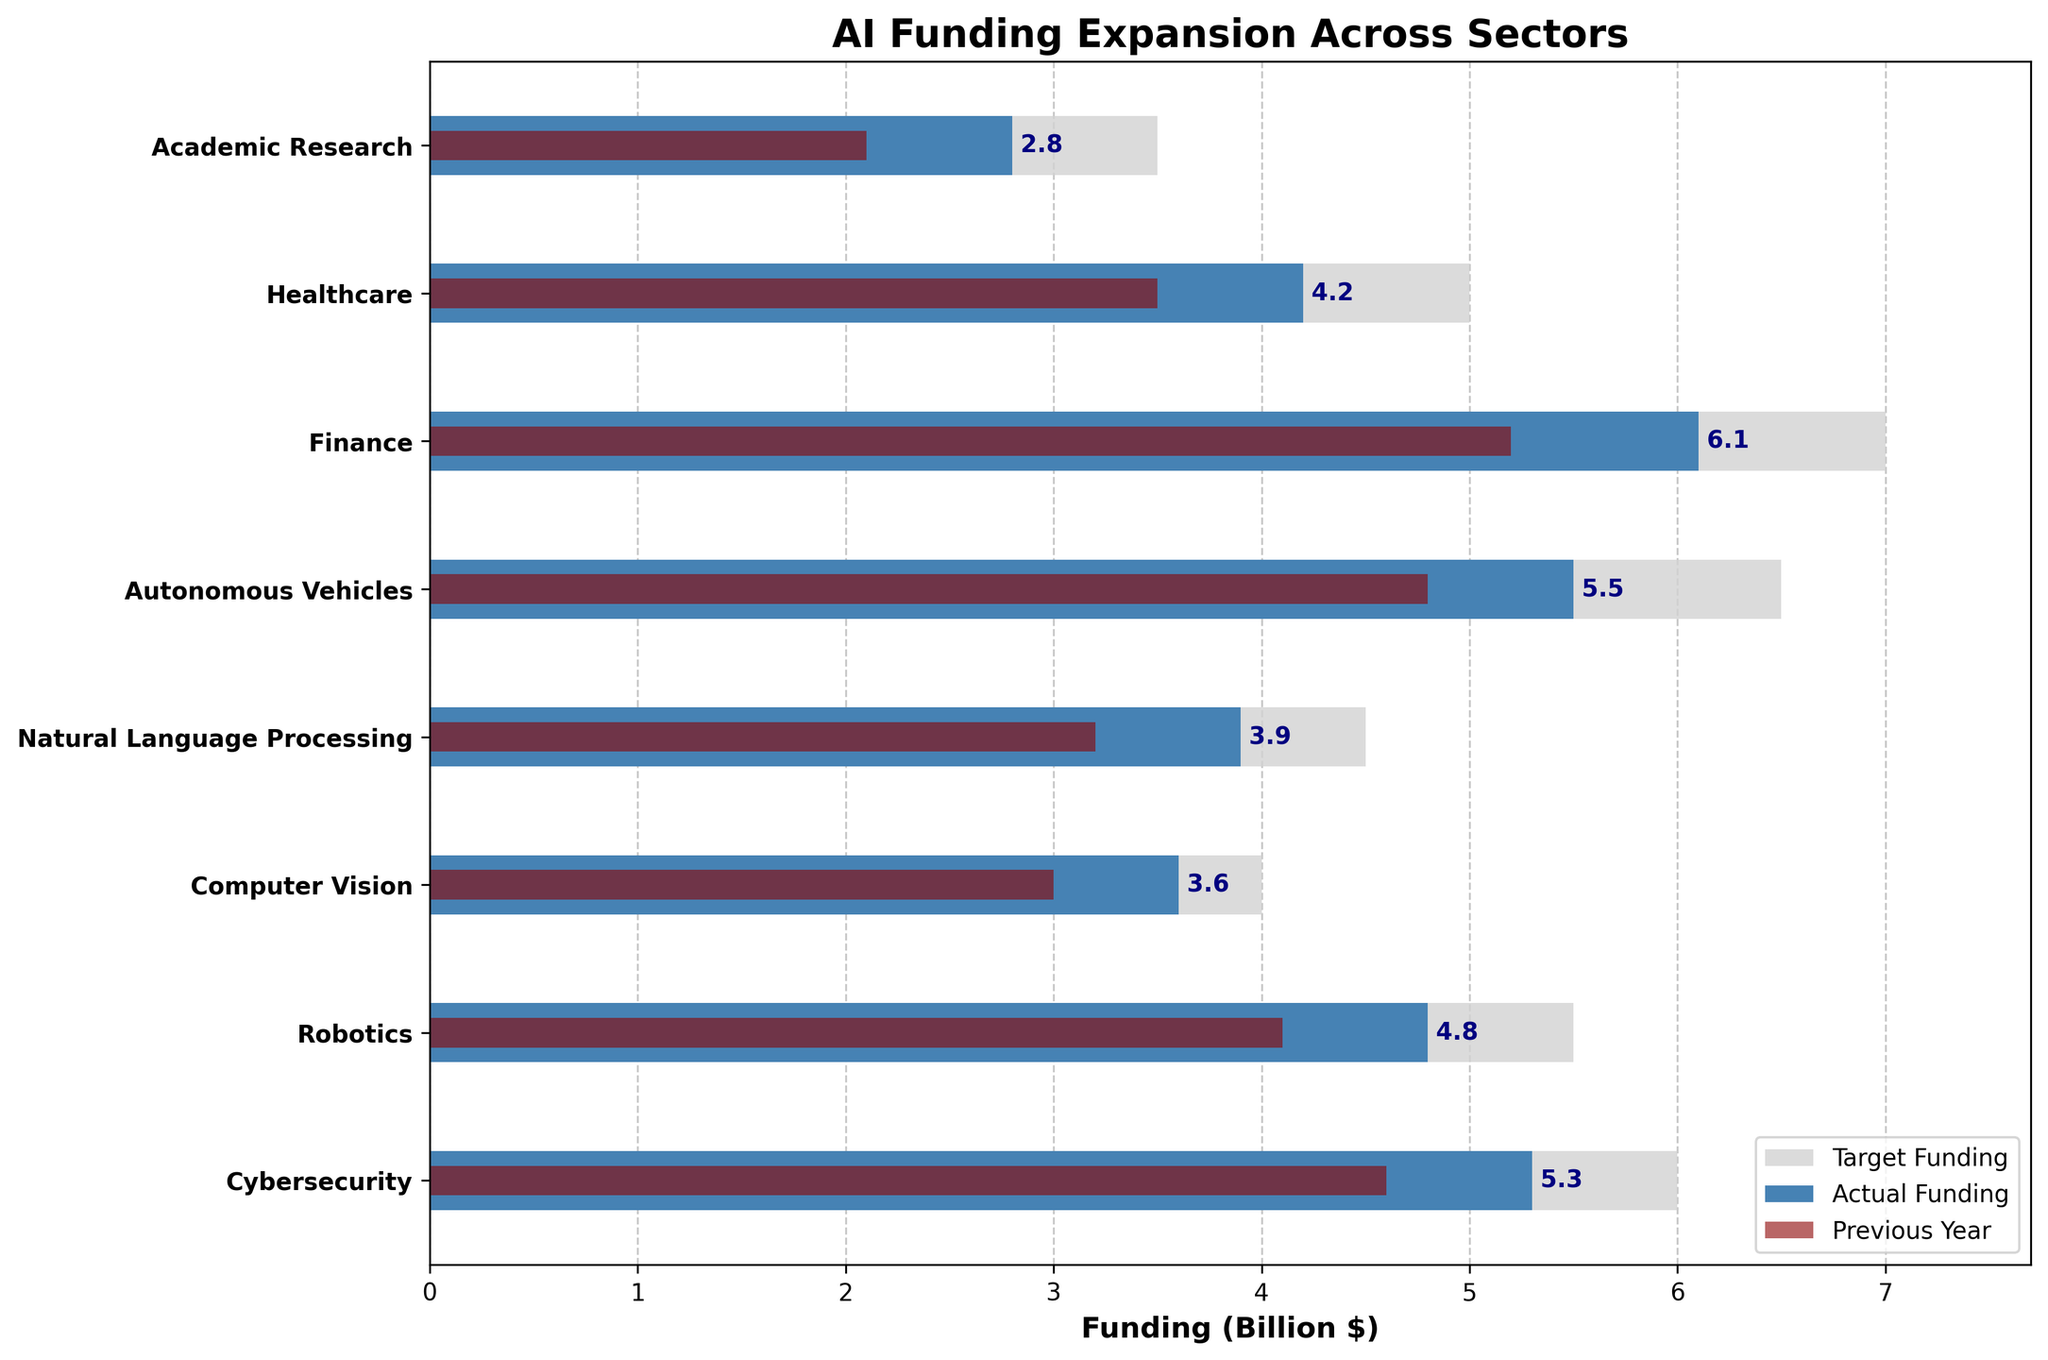What is the title of the chart? The title is typically located at the top of the chart, which is the first thing the viewer sees. It summarizes the main topic of the figure.
Answer: AI Funding Expansion Across Sectors Which sector received the highest actual funding? To answer this question, we need to look at the longest actual funding bar.
Answer: Finance What is the difference between the target and actual funding in the Healthcare sector? Subtract the actual funding from the target funding to find the difference. The target funding is 5.0 billion, and the actual funding is 4.2 billion, so the difference is 5.0 - 4.2.
Answer: 0.8 billion Which sector has the smallest increase in funding from the previous year? To find this, we need to look at the previous year and actual funding bars and identify the sector with the smallest difference. By comparing all sectors, we find that Academic Research has a difference of 0.7 billion (2.8 - 2.1), which is the smallest.
Answer: Academic Research What is the combined actual funding for the Finance and Autonomous Vehicles sectors? Add the actual funding for Finance (6.1 billion) and Autonomous Vehicles (5.5 billion). The combined funding is 6.1 + 5.5.
Answer: 11.6 billion Which sector is second in terms of target funding? To determine this, we need to look at the second-longest target funding bar. Healthcare has a target funding of 5.0 billion, which is the second highest after Finance.
Answer: Healthcare How does the target funding of Robotics compare to its actual funding? Compare the target and actual funding bars for the Robotics sector. The target funding is 5.5 billion and the actual funding is 4.8 billion. The target funding is higher.
Answer: Target funding is higher than actual What is the shared funding increase (from the previous year to actual funding) for Computer Vision and Cybersecurity? Compute the difference between actual and previous year funding for each sector and sum them: For Computer Vision, (3.6-3.0) = 0.6 billion and for Cybersecurity, (5.3-4.6) = 0.7 billion. The total increase is 0.6 + 0.7.
Answer: 1.3 billion What percentage of its target funding did the Natural Language Processing sector achieve? Divide the actual funding by the target funding and multiply by 100 to get the percentage. Natural Language Processing actual funding is 3.9 billion, and target funding is 4.5 billion. So, the percentage is (3.9/4.5) * 100.
Answer: 86.7% Which sector has an actual funding greater than its previous year funding but less than its target funding? Identify the sectors that meet this condition by comparing the actual funding with the previous year and target funding for each sector. All sectors meet this condition since they all increased their funding from the previous year but didn't meet their target.
Answer: All sectors 